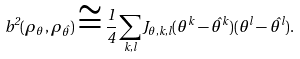Convert formula to latex. <formula><loc_0><loc_0><loc_500><loc_500>b ^ { 2 } ( \rho _ { \theta } , \rho _ { \hat { \theta } } ) \cong \frac { 1 } { 4 } \sum _ { k , l } J _ { \theta , k , l } ( \theta ^ { k } - \hat { \theta } ^ { k } ) ( \theta ^ { l } - \hat { \theta } ^ { l } ) .</formula> 